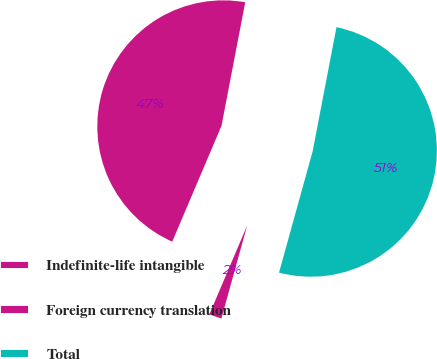<chart> <loc_0><loc_0><loc_500><loc_500><pie_chart><fcel>Indefinite-life intangible<fcel>Foreign currency translation<fcel>Total<nl><fcel>46.62%<fcel>2.1%<fcel>51.28%<nl></chart> 